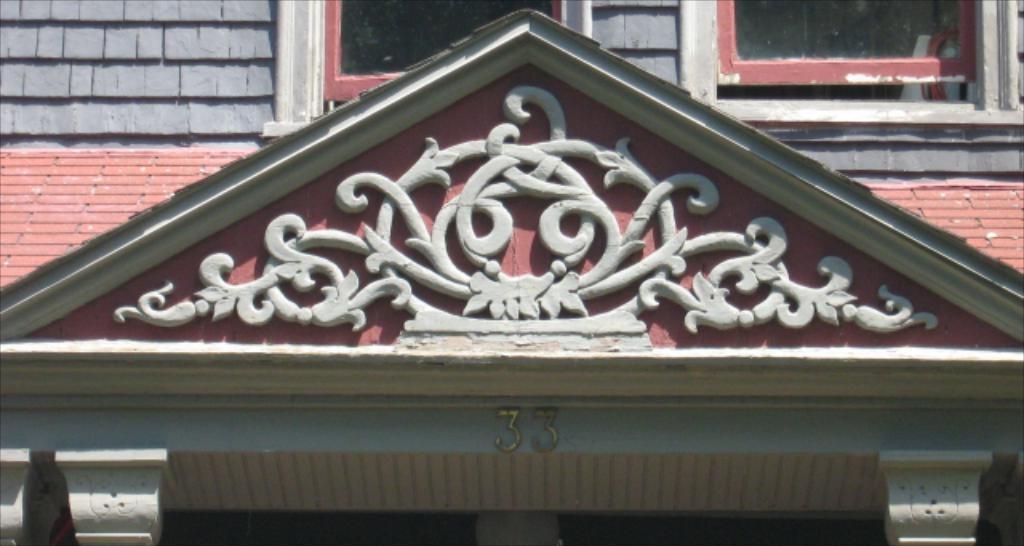Can you describe this image briefly? In this image we can see there is a gable roof in the middle. On it there is some design. In the background there is a building to which there are two windows. At the bottom there is some number on the wall. 